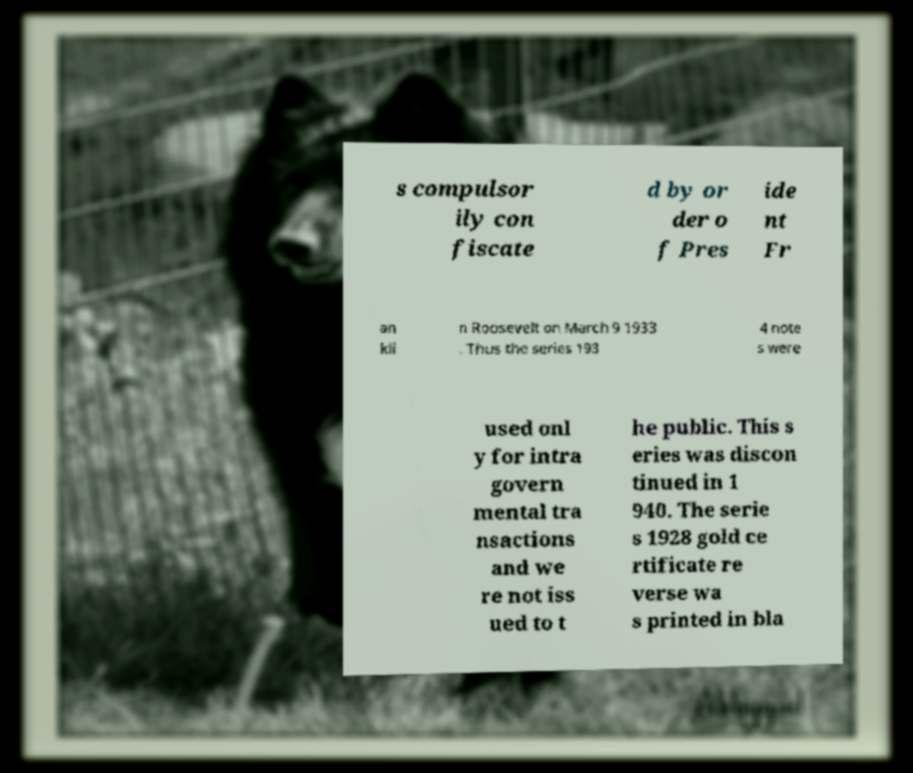For documentation purposes, I need the text within this image transcribed. Could you provide that? s compulsor ily con fiscate d by or der o f Pres ide nt Fr an kli n Roosevelt on March 9 1933 . Thus the series 193 4 note s were used onl y for intra govern mental tra nsactions and we re not iss ued to t he public. This s eries was discon tinued in 1 940. The serie s 1928 gold ce rtificate re verse wa s printed in bla 